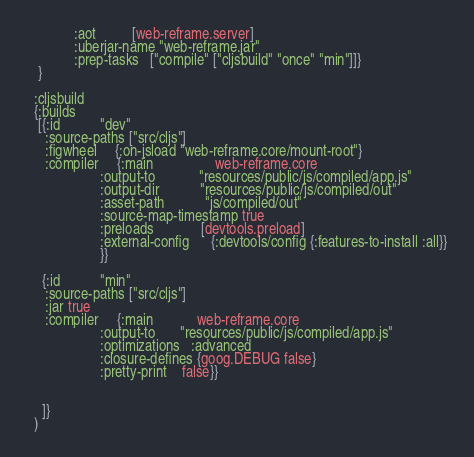Convert code to text. <code><loc_0><loc_0><loc_500><loc_500><_Clojure_>             :aot          [web-reframe.server]
             :uberjar-name "web-reframe.jar"
             :prep-tasks   ["compile" ["cljsbuild" "once" "min"]]}
   }

  :cljsbuild
  {:builds
   [{:id           "dev"
     :source-paths ["src/cljs"]
     :figwheel     {:on-jsload "web-reframe.core/mount-root"}
     :compiler     {:main                 web-reframe.core
                    :output-to            "resources/public/js/compiled/app.js"
                    :output-dir           "resources/public/js/compiled/out"
                    :asset-path           "js/compiled/out"
                    :source-map-timestamp true
                    :preloads             [devtools.preload]
                    :external-config      {:devtools/config {:features-to-install :all}}
                    }}

    {:id           "min"
     :source-paths ["src/cljs"]
     :jar true
     :compiler     {:main            web-reframe.core
                    :output-to       "resources/public/js/compiled/app.js"
                    :optimizations   :advanced
                    :closure-defines {goog.DEBUG false}
                    :pretty-print    false}}


    ]}
  )
</code> 